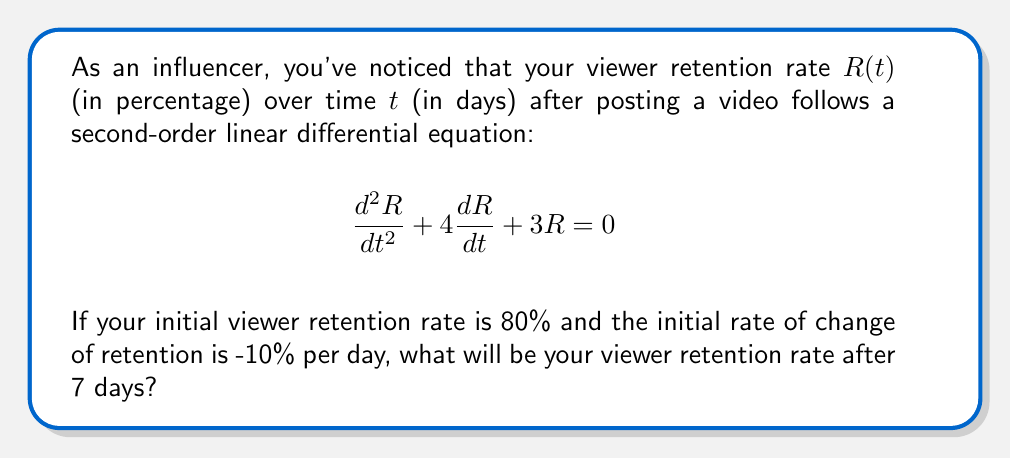Show me your answer to this math problem. To solve this problem, we need to follow these steps:

1) The general solution for this second-order linear differential equation is:

   $$R(t) = c_1e^{-t} + c_2e^{-3t}$$

2) We have two initial conditions:
   $R(0) = 80$ (initial retention rate)
   $R'(0) = -10$ (initial rate of change)

3) Let's use these conditions to find $c_1$ and $c_2$:

   For $R(0) = 80$:
   $$80 = c_1 + c_2$$

   For $R'(0) = -10$:
   $$R'(t) = -c_1e^{-t} - 3c_2e^{-3t}$$
   $$-10 = -c_1 - 3c_2$$

4) Solving these equations:
   $c_1 + c_2 = 80$
   $c_1 + 3c_2 = 10$

   Subtracting the second equation from the first:
   $-2c_2 = 70$
   $c_2 = -35$

   Substituting back:
   $c_1 + (-35) = 80$
   $c_1 = 115$

5) Now our specific solution is:
   $$R(t) = 115e^{-t} - 35e^{-3t}$$

6) To find the retention rate after 7 days, we calculate $R(7)$:

   $$R(7) = 115e^{-7} - 35e^{-21}$$

7) Using a calculator:
   $$R(7) \approx 115 * 0.0009119 - 35 * 0.0000000076 \approx 0.1048$$

8) Converting to a percentage:
   $0.1048 * 100\% \approx 10.48\%$
Answer: The viewer retention rate after 7 days will be approximately 10.48%. 